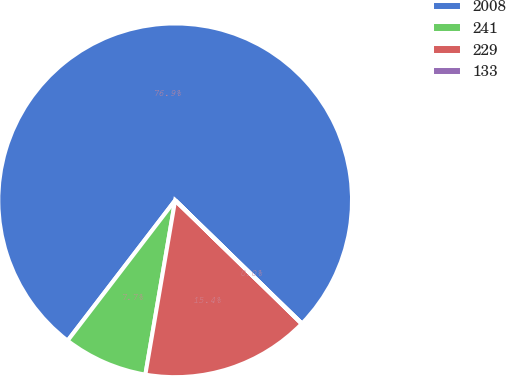Convert chart. <chart><loc_0><loc_0><loc_500><loc_500><pie_chart><fcel>2008<fcel>241<fcel>229<fcel>133<nl><fcel>76.87%<fcel>7.71%<fcel>15.39%<fcel>0.03%<nl></chart> 